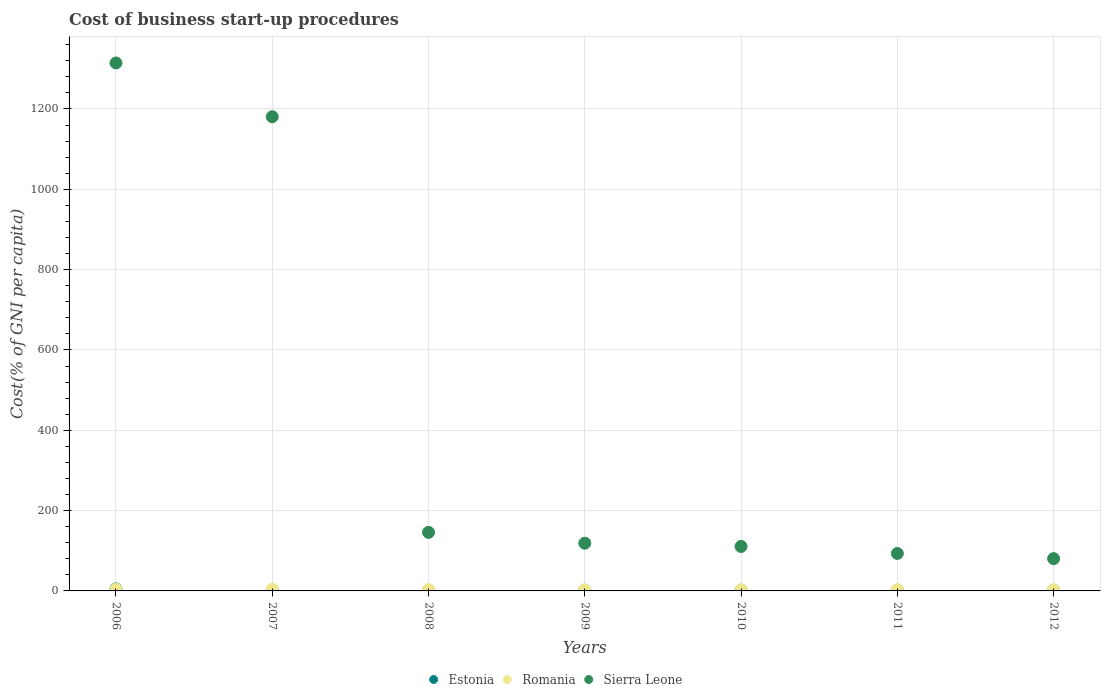Is the number of dotlines equal to the number of legend labels?
Keep it short and to the point. Yes. Across all years, what is the maximum cost of business start-up procedures in Sierra Leone?
Offer a terse response. 1314.6. Across all years, what is the minimum cost of business start-up procedures in Estonia?
Your answer should be very brief. 1.6. In which year was the cost of business start-up procedures in Romania maximum?
Make the answer very short. 2007. In which year was the cost of business start-up procedures in Sierra Leone minimum?
Give a very brief answer. 2012. What is the total cost of business start-up procedures in Romania in the graph?
Make the answer very short. 23.6. What is the difference between the cost of business start-up procedures in Sierra Leone in 2007 and that in 2009?
Keep it short and to the point. 1061.9. What is the difference between the cost of business start-up procedures in Estonia in 2006 and the cost of business start-up procedures in Sierra Leone in 2010?
Ensure brevity in your answer.  -105.6. What is the average cost of business start-up procedures in Estonia per year?
Your response must be concise. 2.26. In the year 2011, what is the difference between the cost of business start-up procedures in Romania and cost of business start-up procedures in Estonia?
Provide a succinct answer. 1.2. In how many years, is the cost of business start-up procedures in Romania greater than 80 %?
Ensure brevity in your answer.  0. Is the cost of business start-up procedures in Sierra Leone in 2007 less than that in 2012?
Make the answer very short. No. Is the difference between the cost of business start-up procedures in Romania in 2011 and 2012 greater than the difference between the cost of business start-up procedures in Estonia in 2011 and 2012?
Provide a short and direct response. Yes. What is the difference between the highest and the second highest cost of business start-up procedures in Estonia?
Your answer should be very brief. 3.1. What is the difference between the highest and the lowest cost of business start-up procedures in Sierra Leone?
Make the answer very short. 1234.2. Does the cost of business start-up procedures in Romania monotonically increase over the years?
Make the answer very short. No. Is the cost of business start-up procedures in Estonia strictly greater than the cost of business start-up procedures in Sierra Leone over the years?
Your answer should be very brief. No. Is the cost of business start-up procedures in Romania strictly less than the cost of business start-up procedures in Estonia over the years?
Offer a terse response. No. Are the values on the major ticks of Y-axis written in scientific E-notation?
Keep it short and to the point. No. What is the title of the graph?
Provide a succinct answer. Cost of business start-up procedures. Does "Angola" appear as one of the legend labels in the graph?
Provide a short and direct response. No. What is the label or title of the X-axis?
Keep it short and to the point. Years. What is the label or title of the Y-axis?
Your response must be concise. Cost(% of GNI per capita). What is the Cost(% of GNI per capita) in Sierra Leone in 2006?
Provide a short and direct response. 1314.6. What is the Cost(% of GNI per capita) of Estonia in 2007?
Keep it short and to the point. 2. What is the Cost(% of GNI per capita) in Romania in 2007?
Keep it short and to the point. 4.5. What is the Cost(% of GNI per capita) in Sierra Leone in 2007?
Your answer should be very brief. 1180.7. What is the Cost(% of GNI per capita) of Estonia in 2008?
Give a very brief answer. 1.7. What is the Cost(% of GNI per capita) in Romania in 2008?
Provide a short and direct response. 3.5. What is the Cost(% of GNI per capita) of Sierra Leone in 2008?
Make the answer very short. 145.8. What is the Cost(% of GNI per capita) of Romania in 2009?
Offer a very short reply. 2.8. What is the Cost(% of GNI per capita) in Sierra Leone in 2009?
Ensure brevity in your answer.  118.8. What is the Cost(% of GNI per capita) in Estonia in 2010?
Your response must be concise. 1.9. What is the Cost(% of GNI per capita) in Romania in 2010?
Keep it short and to the point. 2.6. What is the Cost(% of GNI per capita) in Sierra Leone in 2010?
Your response must be concise. 110.7. What is the Cost(% of GNI per capita) of Sierra Leone in 2011?
Offer a very short reply. 93.3. What is the Cost(% of GNI per capita) in Sierra Leone in 2012?
Provide a short and direct response. 80.4. Across all years, what is the maximum Cost(% of GNI per capita) of Romania?
Your answer should be compact. 4.5. Across all years, what is the maximum Cost(% of GNI per capita) in Sierra Leone?
Provide a succinct answer. 1314.6. Across all years, what is the minimum Cost(% of GNI per capita) of Estonia?
Give a very brief answer. 1.6. Across all years, what is the minimum Cost(% of GNI per capita) in Sierra Leone?
Your answer should be compact. 80.4. What is the total Cost(% of GNI per capita) of Estonia in the graph?
Your answer should be compact. 15.8. What is the total Cost(% of GNI per capita) in Romania in the graph?
Give a very brief answer. 23.6. What is the total Cost(% of GNI per capita) in Sierra Leone in the graph?
Ensure brevity in your answer.  3044.3. What is the difference between the Cost(% of GNI per capita) of Estonia in 2006 and that in 2007?
Your response must be concise. 3.1. What is the difference between the Cost(% of GNI per capita) in Sierra Leone in 2006 and that in 2007?
Offer a very short reply. 133.9. What is the difference between the Cost(% of GNI per capita) in Estonia in 2006 and that in 2008?
Make the answer very short. 3.4. What is the difference between the Cost(% of GNI per capita) of Romania in 2006 and that in 2008?
Offer a very short reply. 0.9. What is the difference between the Cost(% of GNI per capita) in Sierra Leone in 2006 and that in 2008?
Your answer should be compact. 1168.8. What is the difference between the Cost(% of GNI per capita) in Estonia in 2006 and that in 2009?
Give a very brief answer. 3.4. What is the difference between the Cost(% of GNI per capita) in Sierra Leone in 2006 and that in 2009?
Offer a terse response. 1195.8. What is the difference between the Cost(% of GNI per capita) in Estonia in 2006 and that in 2010?
Provide a short and direct response. 3.2. What is the difference between the Cost(% of GNI per capita) of Romania in 2006 and that in 2010?
Ensure brevity in your answer.  1.8. What is the difference between the Cost(% of GNI per capita) in Sierra Leone in 2006 and that in 2010?
Ensure brevity in your answer.  1203.9. What is the difference between the Cost(% of GNI per capita) of Estonia in 2006 and that in 2011?
Your response must be concise. 3.3. What is the difference between the Cost(% of GNI per capita) of Romania in 2006 and that in 2011?
Ensure brevity in your answer.  1.4. What is the difference between the Cost(% of GNI per capita) of Sierra Leone in 2006 and that in 2011?
Give a very brief answer. 1221.3. What is the difference between the Cost(% of GNI per capita) in Estonia in 2006 and that in 2012?
Your answer should be compact. 3.5. What is the difference between the Cost(% of GNI per capita) in Romania in 2006 and that in 2012?
Offer a terse response. 1.6. What is the difference between the Cost(% of GNI per capita) in Sierra Leone in 2006 and that in 2012?
Your response must be concise. 1234.2. What is the difference between the Cost(% of GNI per capita) in Romania in 2007 and that in 2008?
Your answer should be compact. 1. What is the difference between the Cost(% of GNI per capita) in Sierra Leone in 2007 and that in 2008?
Keep it short and to the point. 1034.9. What is the difference between the Cost(% of GNI per capita) of Estonia in 2007 and that in 2009?
Provide a succinct answer. 0.3. What is the difference between the Cost(% of GNI per capita) in Romania in 2007 and that in 2009?
Your response must be concise. 1.7. What is the difference between the Cost(% of GNI per capita) of Sierra Leone in 2007 and that in 2009?
Make the answer very short. 1061.9. What is the difference between the Cost(% of GNI per capita) in Romania in 2007 and that in 2010?
Ensure brevity in your answer.  1.9. What is the difference between the Cost(% of GNI per capita) of Sierra Leone in 2007 and that in 2010?
Offer a terse response. 1070. What is the difference between the Cost(% of GNI per capita) in Estonia in 2007 and that in 2011?
Offer a very short reply. 0.2. What is the difference between the Cost(% of GNI per capita) of Romania in 2007 and that in 2011?
Keep it short and to the point. 1.5. What is the difference between the Cost(% of GNI per capita) in Sierra Leone in 2007 and that in 2011?
Give a very brief answer. 1087.4. What is the difference between the Cost(% of GNI per capita) of Sierra Leone in 2007 and that in 2012?
Give a very brief answer. 1100.3. What is the difference between the Cost(% of GNI per capita) in Estonia in 2008 and that in 2010?
Ensure brevity in your answer.  -0.2. What is the difference between the Cost(% of GNI per capita) of Romania in 2008 and that in 2010?
Provide a succinct answer. 0.9. What is the difference between the Cost(% of GNI per capita) in Sierra Leone in 2008 and that in 2010?
Provide a succinct answer. 35.1. What is the difference between the Cost(% of GNI per capita) in Romania in 2008 and that in 2011?
Offer a very short reply. 0.5. What is the difference between the Cost(% of GNI per capita) of Sierra Leone in 2008 and that in 2011?
Offer a very short reply. 52.5. What is the difference between the Cost(% of GNI per capita) in Romania in 2008 and that in 2012?
Offer a terse response. 0.7. What is the difference between the Cost(% of GNI per capita) of Sierra Leone in 2008 and that in 2012?
Ensure brevity in your answer.  65.4. What is the difference between the Cost(% of GNI per capita) in Estonia in 2009 and that in 2010?
Offer a terse response. -0.2. What is the difference between the Cost(% of GNI per capita) of Romania in 2009 and that in 2010?
Keep it short and to the point. 0.2. What is the difference between the Cost(% of GNI per capita) in Sierra Leone in 2009 and that in 2010?
Your response must be concise. 8.1. What is the difference between the Cost(% of GNI per capita) of Sierra Leone in 2009 and that in 2012?
Your answer should be very brief. 38.4. What is the difference between the Cost(% of GNI per capita) in Estonia in 2010 and that in 2011?
Offer a terse response. 0.1. What is the difference between the Cost(% of GNI per capita) in Sierra Leone in 2010 and that in 2011?
Provide a short and direct response. 17.4. What is the difference between the Cost(% of GNI per capita) in Estonia in 2010 and that in 2012?
Make the answer very short. 0.3. What is the difference between the Cost(% of GNI per capita) of Romania in 2010 and that in 2012?
Ensure brevity in your answer.  -0.2. What is the difference between the Cost(% of GNI per capita) in Sierra Leone in 2010 and that in 2012?
Keep it short and to the point. 30.3. What is the difference between the Cost(% of GNI per capita) of Romania in 2011 and that in 2012?
Make the answer very short. 0.2. What is the difference between the Cost(% of GNI per capita) in Sierra Leone in 2011 and that in 2012?
Your response must be concise. 12.9. What is the difference between the Cost(% of GNI per capita) in Estonia in 2006 and the Cost(% of GNI per capita) in Romania in 2007?
Ensure brevity in your answer.  0.6. What is the difference between the Cost(% of GNI per capita) of Estonia in 2006 and the Cost(% of GNI per capita) of Sierra Leone in 2007?
Give a very brief answer. -1175.6. What is the difference between the Cost(% of GNI per capita) in Romania in 2006 and the Cost(% of GNI per capita) in Sierra Leone in 2007?
Ensure brevity in your answer.  -1176.3. What is the difference between the Cost(% of GNI per capita) in Estonia in 2006 and the Cost(% of GNI per capita) in Sierra Leone in 2008?
Your answer should be very brief. -140.7. What is the difference between the Cost(% of GNI per capita) in Romania in 2006 and the Cost(% of GNI per capita) in Sierra Leone in 2008?
Your response must be concise. -141.4. What is the difference between the Cost(% of GNI per capita) in Estonia in 2006 and the Cost(% of GNI per capita) in Romania in 2009?
Make the answer very short. 2.3. What is the difference between the Cost(% of GNI per capita) of Estonia in 2006 and the Cost(% of GNI per capita) of Sierra Leone in 2009?
Ensure brevity in your answer.  -113.7. What is the difference between the Cost(% of GNI per capita) in Romania in 2006 and the Cost(% of GNI per capita) in Sierra Leone in 2009?
Your answer should be very brief. -114.4. What is the difference between the Cost(% of GNI per capita) in Estonia in 2006 and the Cost(% of GNI per capita) in Sierra Leone in 2010?
Offer a terse response. -105.6. What is the difference between the Cost(% of GNI per capita) of Romania in 2006 and the Cost(% of GNI per capita) of Sierra Leone in 2010?
Provide a short and direct response. -106.3. What is the difference between the Cost(% of GNI per capita) of Estonia in 2006 and the Cost(% of GNI per capita) of Romania in 2011?
Ensure brevity in your answer.  2.1. What is the difference between the Cost(% of GNI per capita) of Estonia in 2006 and the Cost(% of GNI per capita) of Sierra Leone in 2011?
Make the answer very short. -88.2. What is the difference between the Cost(% of GNI per capita) in Romania in 2006 and the Cost(% of GNI per capita) in Sierra Leone in 2011?
Give a very brief answer. -88.9. What is the difference between the Cost(% of GNI per capita) in Estonia in 2006 and the Cost(% of GNI per capita) in Romania in 2012?
Provide a short and direct response. 2.3. What is the difference between the Cost(% of GNI per capita) in Estonia in 2006 and the Cost(% of GNI per capita) in Sierra Leone in 2012?
Your answer should be compact. -75.3. What is the difference between the Cost(% of GNI per capita) of Romania in 2006 and the Cost(% of GNI per capita) of Sierra Leone in 2012?
Make the answer very short. -76. What is the difference between the Cost(% of GNI per capita) in Estonia in 2007 and the Cost(% of GNI per capita) in Romania in 2008?
Keep it short and to the point. -1.5. What is the difference between the Cost(% of GNI per capita) in Estonia in 2007 and the Cost(% of GNI per capita) in Sierra Leone in 2008?
Keep it short and to the point. -143.8. What is the difference between the Cost(% of GNI per capita) of Romania in 2007 and the Cost(% of GNI per capita) of Sierra Leone in 2008?
Provide a short and direct response. -141.3. What is the difference between the Cost(% of GNI per capita) in Estonia in 2007 and the Cost(% of GNI per capita) in Romania in 2009?
Your answer should be very brief. -0.8. What is the difference between the Cost(% of GNI per capita) of Estonia in 2007 and the Cost(% of GNI per capita) of Sierra Leone in 2009?
Your response must be concise. -116.8. What is the difference between the Cost(% of GNI per capita) of Romania in 2007 and the Cost(% of GNI per capita) of Sierra Leone in 2009?
Your answer should be compact. -114.3. What is the difference between the Cost(% of GNI per capita) of Estonia in 2007 and the Cost(% of GNI per capita) of Romania in 2010?
Offer a very short reply. -0.6. What is the difference between the Cost(% of GNI per capita) of Estonia in 2007 and the Cost(% of GNI per capita) of Sierra Leone in 2010?
Your answer should be compact. -108.7. What is the difference between the Cost(% of GNI per capita) in Romania in 2007 and the Cost(% of GNI per capita) in Sierra Leone in 2010?
Ensure brevity in your answer.  -106.2. What is the difference between the Cost(% of GNI per capita) of Estonia in 2007 and the Cost(% of GNI per capita) of Romania in 2011?
Give a very brief answer. -1. What is the difference between the Cost(% of GNI per capita) of Estonia in 2007 and the Cost(% of GNI per capita) of Sierra Leone in 2011?
Provide a succinct answer. -91.3. What is the difference between the Cost(% of GNI per capita) in Romania in 2007 and the Cost(% of GNI per capita) in Sierra Leone in 2011?
Offer a terse response. -88.8. What is the difference between the Cost(% of GNI per capita) of Estonia in 2007 and the Cost(% of GNI per capita) of Sierra Leone in 2012?
Give a very brief answer. -78.4. What is the difference between the Cost(% of GNI per capita) of Romania in 2007 and the Cost(% of GNI per capita) of Sierra Leone in 2012?
Keep it short and to the point. -75.9. What is the difference between the Cost(% of GNI per capita) of Estonia in 2008 and the Cost(% of GNI per capita) of Sierra Leone in 2009?
Make the answer very short. -117.1. What is the difference between the Cost(% of GNI per capita) in Romania in 2008 and the Cost(% of GNI per capita) in Sierra Leone in 2009?
Ensure brevity in your answer.  -115.3. What is the difference between the Cost(% of GNI per capita) of Estonia in 2008 and the Cost(% of GNI per capita) of Romania in 2010?
Offer a very short reply. -0.9. What is the difference between the Cost(% of GNI per capita) in Estonia in 2008 and the Cost(% of GNI per capita) in Sierra Leone in 2010?
Keep it short and to the point. -109. What is the difference between the Cost(% of GNI per capita) of Romania in 2008 and the Cost(% of GNI per capita) of Sierra Leone in 2010?
Provide a short and direct response. -107.2. What is the difference between the Cost(% of GNI per capita) in Estonia in 2008 and the Cost(% of GNI per capita) in Sierra Leone in 2011?
Keep it short and to the point. -91.6. What is the difference between the Cost(% of GNI per capita) of Romania in 2008 and the Cost(% of GNI per capita) of Sierra Leone in 2011?
Provide a short and direct response. -89.8. What is the difference between the Cost(% of GNI per capita) in Estonia in 2008 and the Cost(% of GNI per capita) in Romania in 2012?
Make the answer very short. -1.1. What is the difference between the Cost(% of GNI per capita) in Estonia in 2008 and the Cost(% of GNI per capita) in Sierra Leone in 2012?
Keep it short and to the point. -78.7. What is the difference between the Cost(% of GNI per capita) of Romania in 2008 and the Cost(% of GNI per capita) of Sierra Leone in 2012?
Your answer should be compact. -76.9. What is the difference between the Cost(% of GNI per capita) in Estonia in 2009 and the Cost(% of GNI per capita) in Sierra Leone in 2010?
Provide a short and direct response. -109. What is the difference between the Cost(% of GNI per capita) in Romania in 2009 and the Cost(% of GNI per capita) in Sierra Leone in 2010?
Ensure brevity in your answer.  -107.9. What is the difference between the Cost(% of GNI per capita) in Estonia in 2009 and the Cost(% of GNI per capita) in Sierra Leone in 2011?
Provide a short and direct response. -91.6. What is the difference between the Cost(% of GNI per capita) in Romania in 2009 and the Cost(% of GNI per capita) in Sierra Leone in 2011?
Ensure brevity in your answer.  -90.5. What is the difference between the Cost(% of GNI per capita) in Estonia in 2009 and the Cost(% of GNI per capita) in Romania in 2012?
Offer a very short reply. -1.1. What is the difference between the Cost(% of GNI per capita) in Estonia in 2009 and the Cost(% of GNI per capita) in Sierra Leone in 2012?
Your answer should be compact. -78.7. What is the difference between the Cost(% of GNI per capita) in Romania in 2009 and the Cost(% of GNI per capita) in Sierra Leone in 2012?
Ensure brevity in your answer.  -77.6. What is the difference between the Cost(% of GNI per capita) in Estonia in 2010 and the Cost(% of GNI per capita) in Romania in 2011?
Your answer should be compact. -1.1. What is the difference between the Cost(% of GNI per capita) in Estonia in 2010 and the Cost(% of GNI per capita) in Sierra Leone in 2011?
Ensure brevity in your answer.  -91.4. What is the difference between the Cost(% of GNI per capita) in Romania in 2010 and the Cost(% of GNI per capita) in Sierra Leone in 2011?
Keep it short and to the point. -90.7. What is the difference between the Cost(% of GNI per capita) of Estonia in 2010 and the Cost(% of GNI per capita) of Romania in 2012?
Your answer should be very brief. -0.9. What is the difference between the Cost(% of GNI per capita) in Estonia in 2010 and the Cost(% of GNI per capita) in Sierra Leone in 2012?
Your response must be concise. -78.5. What is the difference between the Cost(% of GNI per capita) in Romania in 2010 and the Cost(% of GNI per capita) in Sierra Leone in 2012?
Provide a short and direct response. -77.8. What is the difference between the Cost(% of GNI per capita) of Estonia in 2011 and the Cost(% of GNI per capita) of Romania in 2012?
Your answer should be very brief. -1. What is the difference between the Cost(% of GNI per capita) of Estonia in 2011 and the Cost(% of GNI per capita) of Sierra Leone in 2012?
Your answer should be very brief. -78.6. What is the difference between the Cost(% of GNI per capita) in Romania in 2011 and the Cost(% of GNI per capita) in Sierra Leone in 2012?
Offer a terse response. -77.4. What is the average Cost(% of GNI per capita) of Estonia per year?
Give a very brief answer. 2.26. What is the average Cost(% of GNI per capita) in Romania per year?
Your response must be concise. 3.37. What is the average Cost(% of GNI per capita) of Sierra Leone per year?
Your response must be concise. 434.9. In the year 2006, what is the difference between the Cost(% of GNI per capita) of Estonia and Cost(% of GNI per capita) of Sierra Leone?
Keep it short and to the point. -1309.5. In the year 2006, what is the difference between the Cost(% of GNI per capita) of Romania and Cost(% of GNI per capita) of Sierra Leone?
Your answer should be very brief. -1310.2. In the year 2007, what is the difference between the Cost(% of GNI per capita) in Estonia and Cost(% of GNI per capita) in Romania?
Your answer should be compact. -2.5. In the year 2007, what is the difference between the Cost(% of GNI per capita) in Estonia and Cost(% of GNI per capita) in Sierra Leone?
Offer a very short reply. -1178.7. In the year 2007, what is the difference between the Cost(% of GNI per capita) of Romania and Cost(% of GNI per capita) of Sierra Leone?
Provide a short and direct response. -1176.2. In the year 2008, what is the difference between the Cost(% of GNI per capita) in Estonia and Cost(% of GNI per capita) in Sierra Leone?
Provide a succinct answer. -144.1. In the year 2008, what is the difference between the Cost(% of GNI per capita) in Romania and Cost(% of GNI per capita) in Sierra Leone?
Your response must be concise. -142.3. In the year 2009, what is the difference between the Cost(% of GNI per capita) in Estonia and Cost(% of GNI per capita) in Romania?
Offer a very short reply. -1.1. In the year 2009, what is the difference between the Cost(% of GNI per capita) in Estonia and Cost(% of GNI per capita) in Sierra Leone?
Give a very brief answer. -117.1. In the year 2009, what is the difference between the Cost(% of GNI per capita) in Romania and Cost(% of GNI per capita) in Sierra Leone?
Offer a very short reply. -116. In the year 2010, what is the difference between the Cost(% of GNI per capita) in Estonia and Cost(% of GNI per capita) in Sierra Leone?
Your answer should be compact. -108.8. In the year 2010, what is the difference between the Cost(% of GNI per capita) in Romania and Cost(% of GNI per capita) in Sierra Leone?
Your answer should be very brief. -108.1. In the year 2011, what is the difference between the Cost(% of GNI per capita) in Estonia and Cost(% of GNI per capita) in Sierra Leone?
Offer a very short reply. -91.5. In the year 2011, what is the difference between the Cost(% of GNI per capita) of Romania and Cost(% of GNI per capita) of Sierra Leone?
Give a very brief answer. -90.3. In the year 2012, what is the difference between the Cost(% of GNI per capita) of Estonia and Cost(% of GNI per capita) of Sierra Leone?
Offer a very short reply. -78.8. In the year 2012, what is the difference between the Cost(% of GNI per capita) of Romania and Cost(% of GNI per capita) of Sierra Leone?
Offer a very short reply. -77.6. What is the ratio of the Cost(% of GNI per capita) in Estonia in 2006 to that in 2007?
Offer a terse response. 2.55. What is the ratio of the Cost(% of GNI per capita) of Romania in 2006 to that in 2007?
Your answer should be compact. 0.98. What is the ratio of the Cost(% of GNI per capita) of Sierra Leone in 2006 to that in 2007?
Your answer should be compact. 1.11. What is the ratio of the Cost(% of GNI per capita) of Romania in 2006 to that in 2008?
Offer a terse response. 1.26. What is the ratio of the Cost(% of GNI per capita) of Sierra Leone in 2006 to that in 2008?
Make the answer very short. 9.02. What is the ratio of the Cost(% of GNI per capita) of Estonia in 2006 to that in 2009?
Keep it short and to the point. 3. What is the ratio of the Cost(% of GNI per capita) of Romania in 2006 to that in 2009?
Provide a succinct answer. 1.57. What is the ratio of the Cost(% of GNI per capita) of Sierra Leone in 2006 to that in 2009?
Give a very brief answer. 11.07. What is the ratio of the Cost(% of GNI per capita) of Estonia in 2006 to that in 2010?
Your answer should be very brief. 2.68. What is the ratio of the Cost(% of GNI per capita) of Romania in 2006 to that in 2010?
Your answer should be compact. 1.69. What is the ratio of the Cost(% of GNI per capita) in Sierra Leone in 2006 to that in 2010?
Keep it short and to the point. 11.88. What is the ratio of the Cost(% of GNI per capita) in Estonia in 2006 to that in 2011?
Provide a succinct answer. 2.83. What is the ratio of the Cost(% of GNI per capita) in Romania in 2006 to that in 2011?
Your answer should be compact. 1.47. What is the ratio of the Cost(% of GNI per capita) of Sierra Leone in 2006 to that in 2011?
Ensure brevity in your answer.  14.09. What is the ratio of the Cost(% of GNI per capita) in Estonia in 2006 to that in 2012?
Offer a very short reply. 3.19. What is the ratio of the Cost(% of GNI per capita) of Romania in 2006 to that in 2012?
Provide a short and direct response. 1.57. What is the ratio of the Cost(% of GNI per capita) in Sierra Leone in 2006 to that in 2012?
Ensure brevity in your answer.  16.35. What is the ratio of the Cost(% of GNI per capita) of Estonia in 2007 to that in 2008?
Ensure brevity in your answer.  1.18. What is the ratio of the Cost(% of GNI per capita) in Romania in 2007 to that in 2008?
Your answer should be very brief. 1.29. What is the ratio of the Cost(% of GNI per capita) of Sierra Leone in 2007 to that in 2008?
Your answer should be very brief. 8.1. What is the ratio of the Cost(% of GNI per capita) in Estonia in 2007 to that in 2009?
Provide a succinct answer. 1.18. What is the ratio of the Cost(% of GNI per capita) of Romania in 2007 to that in 2009?
Provide a succinct answer. 1.61. What is the ratio of the Cost(% of GNI per capita) of Sierra Leone in 2007 to that in 2009?
Make the answer very short. 9.94. What is the ratio of the Cost(% of GNI per capita) in Estonia in 2007 to that in 2010?
Offer a very short reply. 1.05. What is the ratio of the Cost(% of GNI per capita) in Romania in 2007 to that in 2010?
Your response must be concise. 1.73. What is the ratio of the Cost(% of GNI per capita) in Sierra Leone in 2007 to that in 2010?
Your response must be concise. 10.67. What is the ratio of the Cost(% of GNI per capita) in Sierra Leone in 2007 to that in 2011?
Provide a short and direct response. 12.65. What is the ratio of the Cost(% of GNI per capita) of Romania in 2007 to that in 2012?
Your response must be concise. 1.61. What is the ratio of the Cost(% of GNI per capita) in Sierra Leone in 2007 to that in 2012?
Offer a terse response. 14.69. What is the ratio of the Cost(% of GNI per capita) of Estonia in 2008 to that in 2009?
Offer a very short reply. 1. What is the ratio of the Cost(% of GNI per capita) of Romania in 2008 to that in 2009?
Make the answer very short. 1.25. What is the ratio of the Cost(% of GNI per capita) in Sierra Leone in 2008 to that in 2009?
Give a very brief answer. 1.23. What is the ratio of the Cost(% of GNI per capita) in Estonia in 2008 to that in 2010?
Keep it short and to the point. 0.89. What is the ratio of the Cost(% of GNI per capita) in Romania in 2008 to that in 2010?
Offer a very short reply. 1.35. What is the ratio of the Cost(% of GNI per capita) in Sierra Leone in 2008 to that in 2010?
Ensure brevity in your answer.  1.32. What is the ratio of the Cost(% of GNI per capita) in Estonia in 2008 to that in 2011?
Keep it short and to the point. 0.94. What is the ratio of the Cost(% of GNI per capita) of Romania in 2008 to that in 2011?
Give a very brief answer. 1.17. What is the ratio of the Cost(% of GNI per capita) in Sierra Leone in 2008 to that in 2011?
Offer a very short reply. 1.56. What is the ratio of the Cost(% of GNI per capita) in Romania in 2008 to that in 2012?
Provide a succinct answer. 1.25. What is the ratio of the Cost(% of GNI per capita) in Sierra Leone in 2008 to that in 2012?
Make the answer very short. 1.81. What is the ratio of the Cost(% of GNI per capita) of Estonia in 2009 to that in 2010?
Keep it short and to the point. 0.89. What is the ratio of the Cost(% of GNI per capita) of Sierra Leone in 2009 to that in 2010?
Your answer should be very brief. 1.07. What is the ratio of the Cost(% of GNI per capita) of Sierra Leone in 2009 to that in 2011?
Make the answer very short. 1.27. What is the ratio of the Cost(% of GNI per capita) of Estonia in 2009 to that in 2012?
Ensure brevity in your answer.  1.06. What is the ratio of the Cost(% of GNI per capita) in Romania in 2009 to that in 2012?
Your answer should be very brief. 1. What is the ratio of the Cost(% of GNI per capita) of Sierra Leone in 2009 to that in 2012?
Provide a short and direct response. 1.48. What is the ratio of the Cost(% of GNI per capita) of Estonia in 2010 to that in 2011?
Offer a very short reply. 1.06. What is the ratio of the Cost(% of GNI per capita) in Romania in 2010 to that in 2011?
Offer a very short reply. 0.87. What is the ratio of the Cost(% of GNI per capita) of Sierra Leone in 2010 to that in 2011?
Your answer should be very brief. 1.19. What is the ratio of the Cost(% of GNI per capita) of Estonia in 2010 to that in 2012?
Your answer should be very brief. 1.19. What is the ratio of the Cost(% of GNI per capita) in Sierra Leone in 2010 to that in 2012?
Offer a terse response. 1.38. What is the ratio of the Cost(% of GNI per capita) in Estonia in 2011 to that in 2012?
Provide a succinct answer. 1.12. What is the ratio of the Cost(% of GNI per capita) of Romania in 2011 to that in 2012?
Provide a succinct answer. 1.07. What is the ratio of the Cost(% of GNI per capita) in Sierra Leone in 2011 to that in 2012?
Make the answer very short. 1.16. What is the difference between the highest and the second highest Cost(% of GNI per capita) in Estonia?
Offer a very short reply. 3.1. What is the difference between the highest and the second highest Cost(% of GNI per capita) in Romania?
Offer a very short reply. 0.1. What is the difference between the highest and the second highest Cost(% of GNI per capita) of Sierra Leone?
Keep it short and to the point. 133.9. What is the difference between the highest and the lowest Cost(% of GNI per capita) in Estonia?
Offer a very short reply. 3.5. What is the difference between the highest and the lowest Cost(% of GNI per capita) of Romania?
Give a very brief answer. 1.9. What is the difference between the highest and the lowest Cost(% of GNI per capita) in Sierra Leone?
Offer a terse response. 1234.2. 